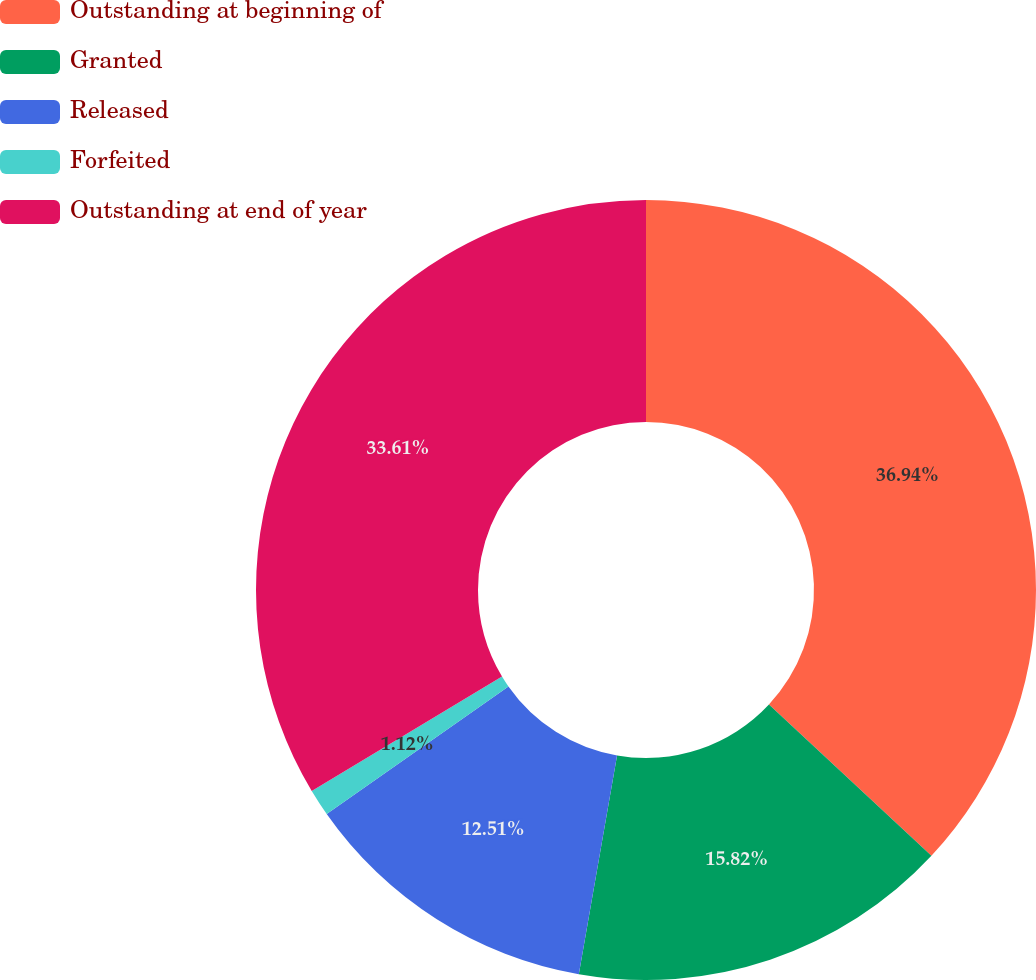Convert chart to OTSL. <chart><loc_0><loc_0><loc_500><loc_500><pie_chart><fcel>Outstanding at beginning of<fcel>Granted<fcel>Released<fcel>Forfeited<fcel>Outstanding at end of year<nl><fcel>36.93%<fcel>15.82%<fcel>12.51%<fcel>1.12%<fcel>33.61%<nl></chart> 